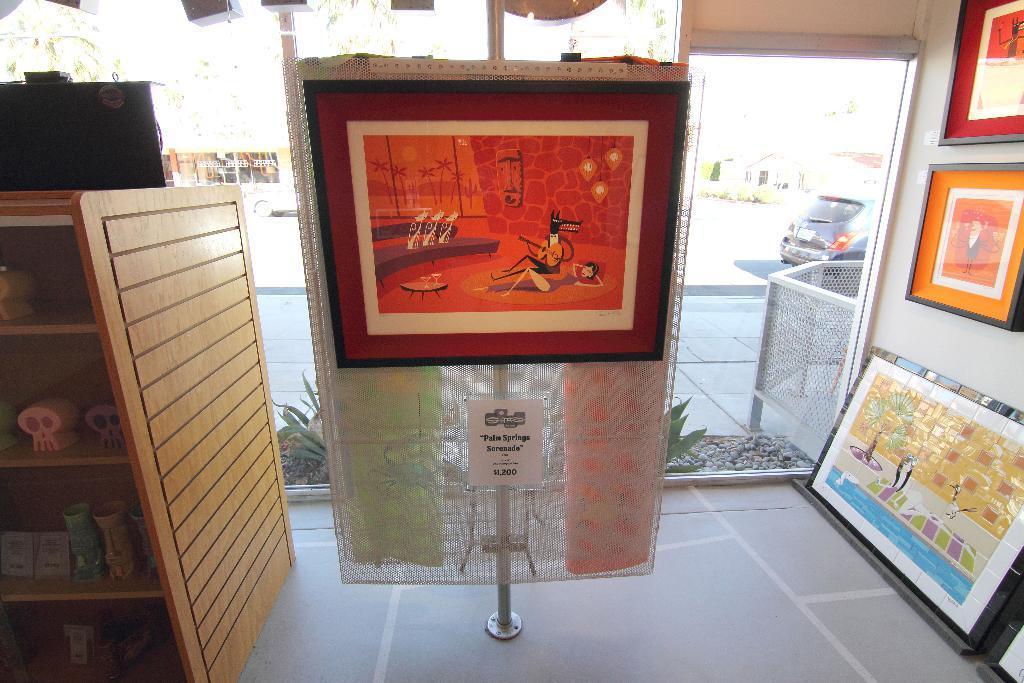In one or two sentences, can you explain what this image depicts? In this picture we can see a stand in the front, there are some portraits present on the right side, on the left side we can see a rack, there are some things present on the rack, on the right side we can see a glass, from the glass we can see a plant, stones, a car and a house, we can also see a paper in the front, there is some text on this paper. 